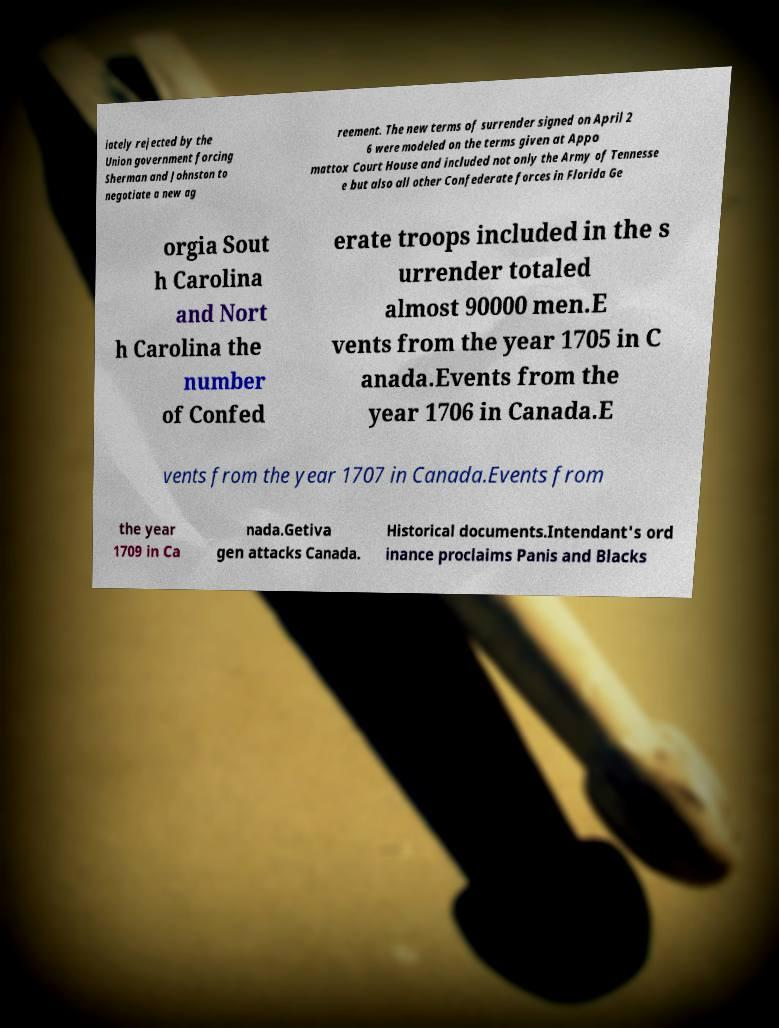I need the written content from this picture converted into text. Can you do that? iately rejected by the Union government forcing Sherman and Johnston to negotiate a new ag reement. The new terms of surrender signed on April 2 6 were modeled on the terms given at Appo mattox Court House and included not only the Army of Tennesse e but also all other Confederate forces in Florida Ge orgia Sout h Carolina and Nort h Carolina the number of Confed erate troops included in the s urrender totaled almost 90000 men.E vents from the year 1705 in C anada.Events from the year 1706 in Canada.E vents from the year 1707 in Canada.Events from the year 1709 in Ca nada.Getiva gen attacks Canada. Historical documents.Intendant's ord inance proclaims Panis and Blacks 